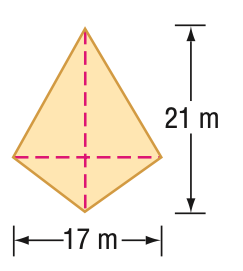Answer the mathemtical geometry problem and directly provide the correct option letter.
Question: Find the area of the kite.
Choices: A: 168 B: 177 C: 178.5 D: 357 C 